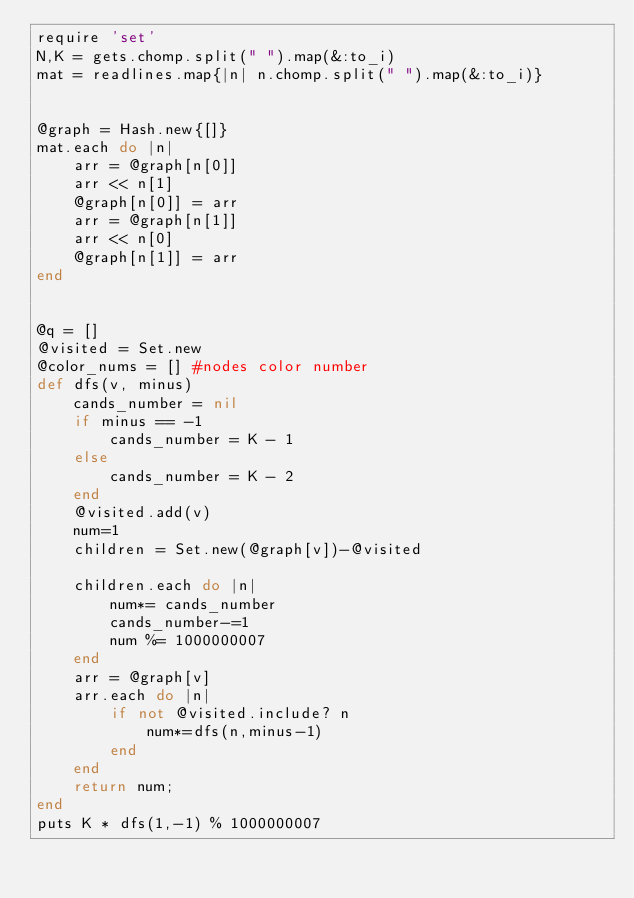<code> <loc_0><loc_0><loc_500><loc_500><_Ruby_>require 'set'
N,K = gets.chomp.split(" ").map(&:to_i)
mat = readlines.map{|n| n.chomp.split(" ").map(&:to_i)}


@graph = Hash.new{[]}
mat.each do |n|
    arr = @graph[n[0]]
    arr << n[1]
    @graph[n[0]] = arr
    arr = @graph[n[1]]
    arr << n[0]
    @graph[n[1]] = arr
end


@q = []
@visited = Set.new
@color_nums = [] #nodes color number
def dfs(v, minus)
    cands_number = nil
    if minus == -1
        cands_number = K - 1
    else
        cands_number = K - 2
    end
    @visited.add(v)
    num=1
    children = Set.new(@graph[v])-@visited

    children.each do |n|
        num*= cands_number
        cands_number-=1
        num %= 1000000007
    end
    arr = @graph[v]
    arr.each do |n|
        if not @visited.include? n
            num*=dfs(n,minus-1)
        end
    end
    return num;
end
puts K * dfs(1,-1) % 1000000007</code> 